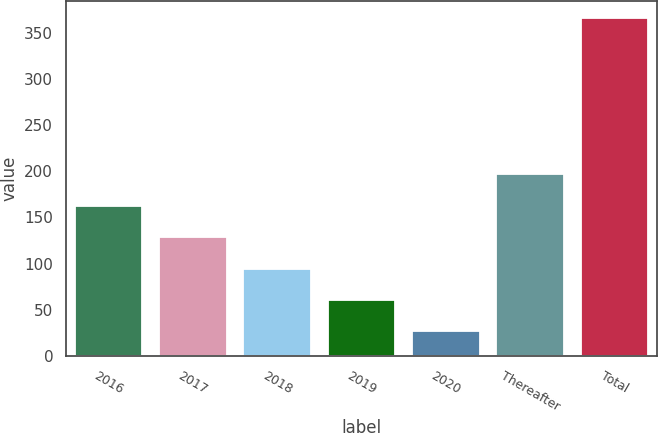<chart> <loc_0><loc_0><loc_500><loc_500><bar_chart><fcel>2016<fcel>2017<fcel>2018<fcel>2019<fcel>2020<fcel>Thereafter<fcel>Total<nl><fcel>162.52<fcel>128.49<fcel>94.46<fcel>60.43<fcel>26.4<fcel>196.55<fcel>366.7<nl></chart> 